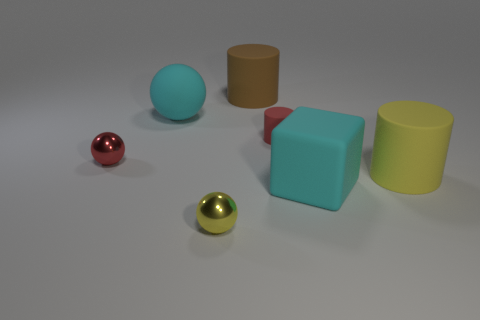What time of day does the lighting in the image suggest? The lighting in the image doesn't strongly suggest any particular time of day since it appears to be artificial and controlled, possibly coming from a neutral overhead light source, which is common in indoor or studio settings. 